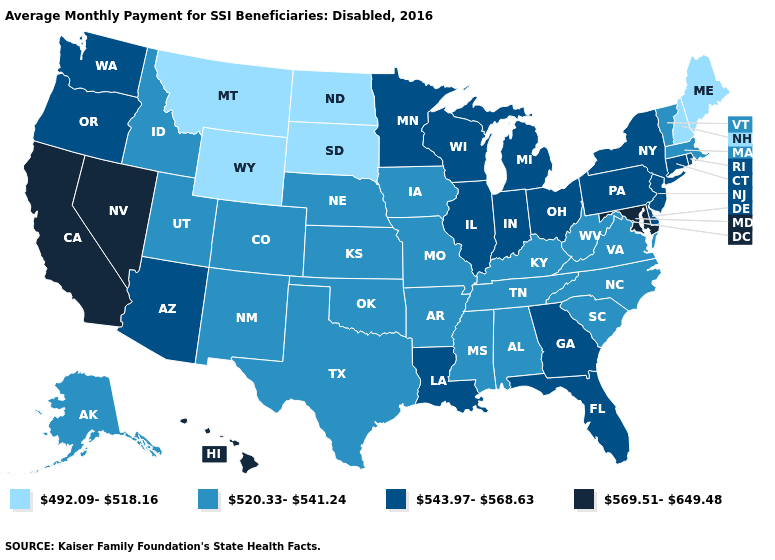How many symbols are there in the legend?
Short answer required. 4. Which states have the lowest value in the USA?
Write a very short answer. Maine, Montana, New Hampshire, North Dakota, South Dakota, Wyoming. What is the highest value in the USA?
Short answer required. 569.51-649.48. What is the value of Idaho?
Answer briefly. 520.33-541.24. What is the value of Rhode Island?
Keep it brief. 543.97-568.63. Name the states that have a value in the range 543.97-568.63?
Be succinct. Arizona, Connecticut, Delaware, Florida, Georgia, Illinois, Indiana, Louisiana, Michigan, Minnesota, New Jersey, New York, Ohio, Oregon, Pennsylvania, Rhode Island, Washington, Wisconsin. Does New Mexico have the highest value in the West?
Write a very short answer. No. Which states have the lowest value in the USA?
Be succinct. Maine, Montana, New Hampshire, North Dakota, South Dakota, Wyoming. What is the value of Kentucky?
Short answer required. 520.33-541.24. What is the lowest value in states that border Texas?
Be succinct. 520.33-541.24. Which states hav the highest value in the MidWest?
Be succinct. Illinois, Indiana, Michigan, Minnesota, Ohio, Wisconsin. What is the lowest value in the West?
Write a very short answer. 492.09-518.16. Which states have the lowest value in the West?
Answer briefly. Montana, Wyoming. Which states have the lowest value in the USA?
Give a very brief answer. Maine, Montana, New Hampshire, North Dakota, South Dakota, Wyoming. 